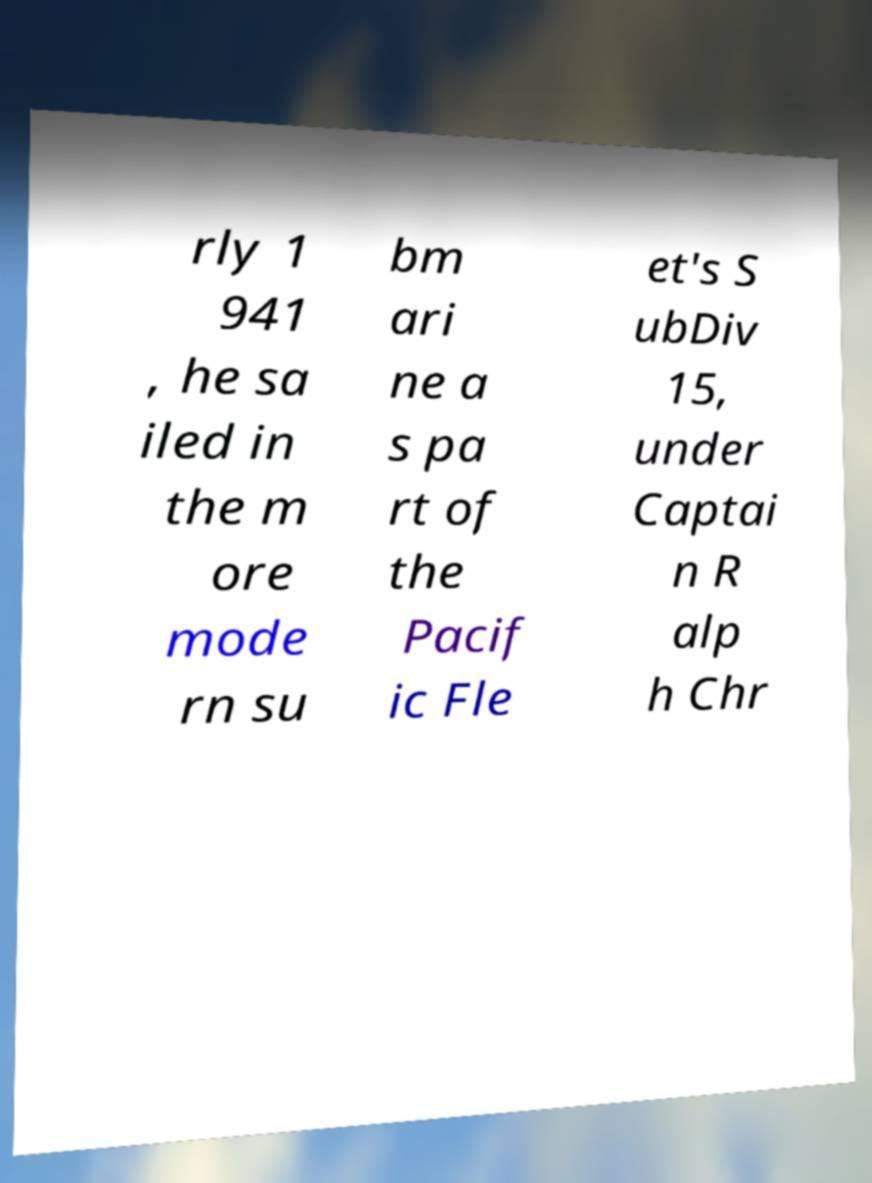Can you accurately transcribe the text from the provided image for me? rly 1 941 , he sa iled in the m ore mode rn su bm ari ne a s pa rt of the Pacif ic Fle et's S ubDiv 15, under Captai n R alp h Chr 